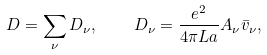Convert formula to latex. <formula><loc_0><loc_0><loc_500><loc_500>D = \sum _ { \nu } D _ { \nu } , \quad D _ { \nu } = \frac { e ^ { 2 } } { 4 \pi L a } A _ { \nu } \bar { v } _ { \nu } ,</formula> 